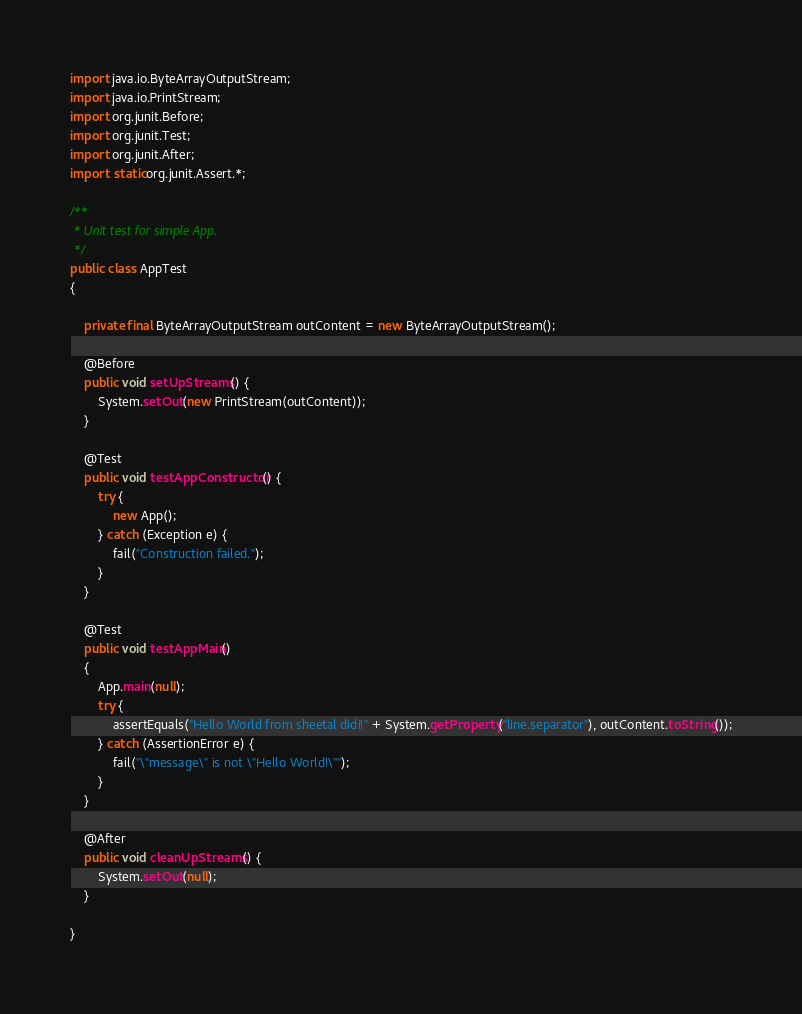Convert code to text. <code><loc_0><loc_0><loc_500><loc_500><_Java_>import java.io.ByteArrayOutputStream;
import java.io.PrintStream;
import org.junit.Before;
import org.junit.Test;
import org.junit.After;
import static org.junit.Assert.*;

/**
 * Unit test for simple App.
 */
public class AppTest
{

    private final ByteArrayOutputStream outContent = new ByteArrayOutputStream();

    @Before
    public void setUpStreams() {
        System.setOut(new PrintStream(outContent));
    }

    @Test
    public void testAppConstructor() {
        try {
            new App();
        } catch (Exception e) {
            fail("Construction failed.");
        }
    }

    @Test
    public void testAppMain()
    {
        App.main(null);
        try {
            assertEquals("Hello World from sheetal didi!" + System.getProperty("line.separator"), outContent.toString());
        } catch (AssertionError e) {
            fail("\"message\" is not \"Hello World!\"");
        }
    }

    @After
    public void cleanUpStreams() {
        System.setOut(null);
    }

}
</code> 